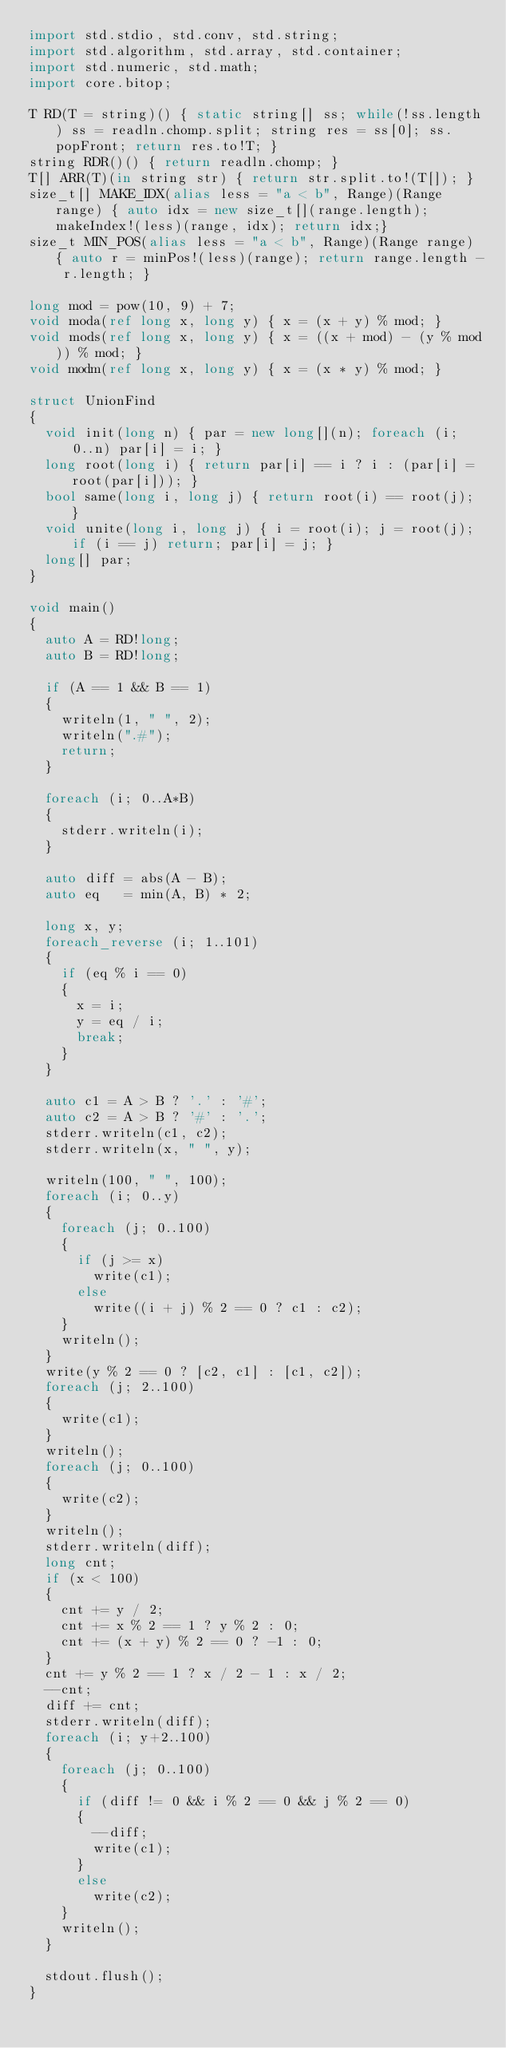<code> <loc_0><loc_0><loc_500><loc_500><_D_>import std.stdio, std.conv, std.string;
import std.algorithm, std.array, std.container;
import std.numeric, std.math;
import core.bitop;

T RD(T = string)() { static string[] ss; while(!ss.length) ss = readln.chomp.split; string res = ss[0]; ss.popFront; return res.to!T; }
string RDR()() { return readln.chomp; }
T[] ARR(T)(in string str) { return str.split.to!(T[]); }
size_t[] MAKE_IDX(alias less = "a < b", Range)(Range range) { auto idx = new size_t[](range.length); makeIndex!(less)(range, idx); return idx;}
size_t MIN_POS(alias less = "a < b", Range)(Range range) { auto r = minPos!(less)(range); return range.length - r.length; }

long mod = pow(10, 9) + 7;
void moda(ref long x, long y) { x = (x + y) % mod; }
void mods(ref long x, long y) { x = ((x + mod) - (y % mod)) % mod; }
void modm(ref long x, long y) { x = (x * y) % mod; }

struct UnionFind
{
	void init(long n) { par = new long[](n); foreach (i; 0..n) par[i] = i; }
	long root(long i) { return par[i] == i ? i : (par[i] = root(par[i])); }
	bool same(long i, long j) { return root(i) == root(j); }
	void unite(long i, long j) { i = root(i); j = root(j); if (i == j) return; par[i] = j; }
	long[] par;
}

void main()
{
	auto A = RD!long;
	auto B = RD!long;

	if (A == 1 && B == 1)
	{
		writeln(1, " ", 2);
		writeln(".#");
		return;
	}

	foreach (i; 0..A*B)
	{
		stderr.writeln(i);
	}

	auto diff = abs(A - B);
	auto eq   = min(A, B) * 2; 

	long x, y;
	foreach_reverse (i; 1..101)
	{
		if (eq % i == 0)
		{
			x = i;
			y = eq / i;
			break;
		}
	}

	auto c1 = A > B ? '.' : '#';
	auto c2 = A > B ? '#' : '.';
	stderr.writeln(c1, c2);
	stderr.writeln(x, " ", y);

	writeln(100, " ", 100);
	foreach (i; 0..y)
	{
		foreach (j; 0..100)
		{
			if (j >= x)
				write(c1);
			else
				write((i + j) % 2 == 0 ? c1 : c2);
		}
		writeln();
	}
	write(y % 2 == 0 ? [c2, c1] : [c1, c2]);
	foreach (j; 2..100)
	{
		write(c1);
	}
	writeln();
	foreach (j; 0..100)
	{
		write(c2);
	}
	writeln();
	stderr.writeln(diff);
	long cnt;
	if (x < 100)
	{
		cnt += y / 2;
		cnt += x % 2 == 1 ? y % 2 : 0;
		cnt += (x + y) % 2 == 0 ? -1 : 0;
	}
	cnt += y % 2 == 1 ? x / 2 - 1 : x / 2;
	--cnt;
	diff += cnt;
	stderr.writeln(diff);
	foreach (i; y+2..100)
	{
		foreach (j; 0..100)
		{
			if (diff != 0 && i % 2 == 0 && j % 2 == 0)
			{
				--diff;
				write(c1);
			}
			else
				write(c2);
		}
		writeln();
	}

	stdout.flush();
}</code> 